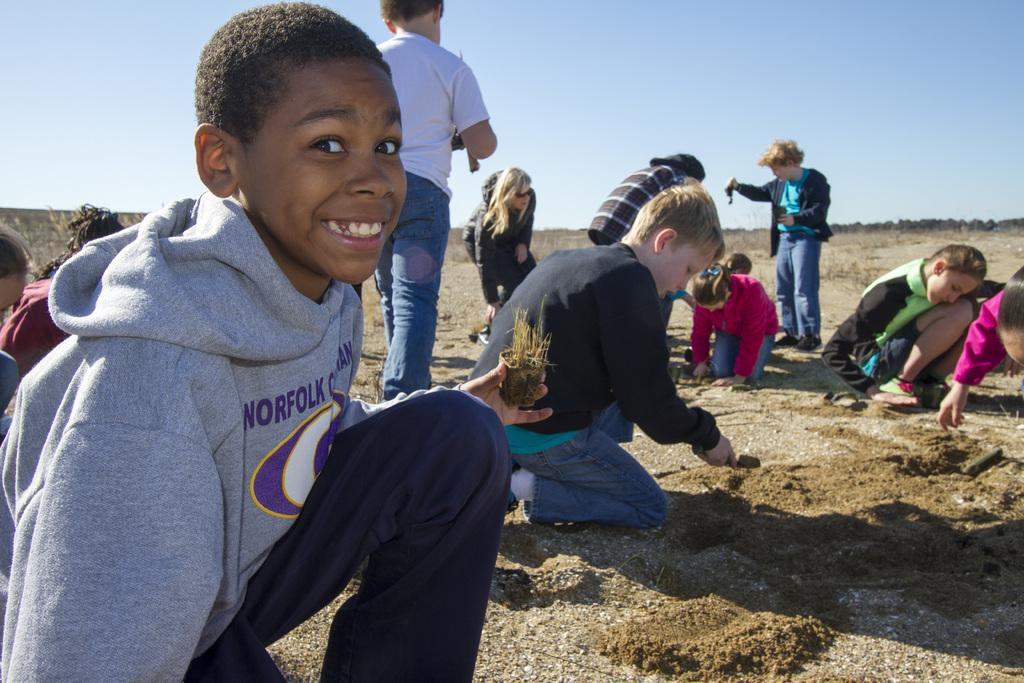What can be seen in the image involving children? There are kids in the image. What activity are the kids engaged in? The kids are playing with sand. Where is the sand located in the image? The sand is on the ground. What type of trousers are the pigs wearing in the image? There are no pigs or trousers present in the image. What message of peace can be seen in the image? There is no message of peace depicted in the image. 